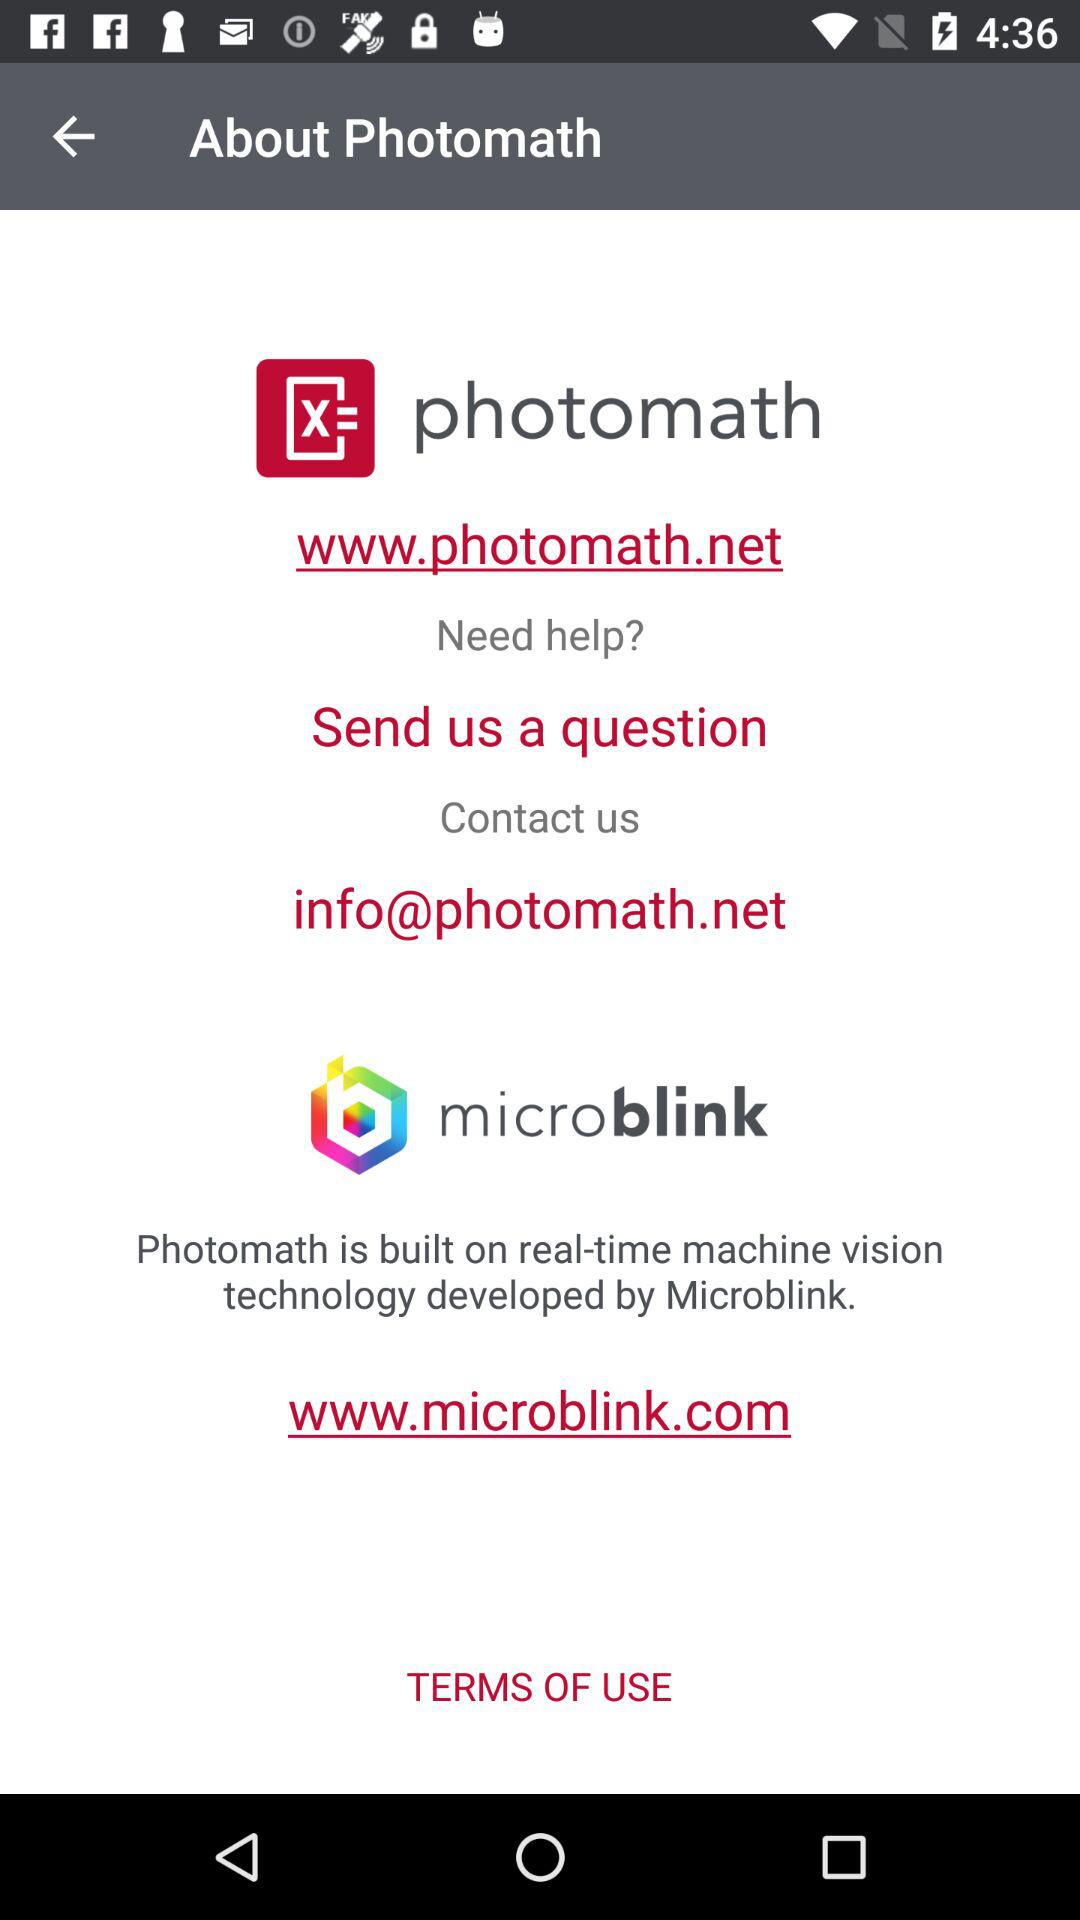What is the web address of "Microblink"? The web address of "Microblink" is www.microblink.com. 